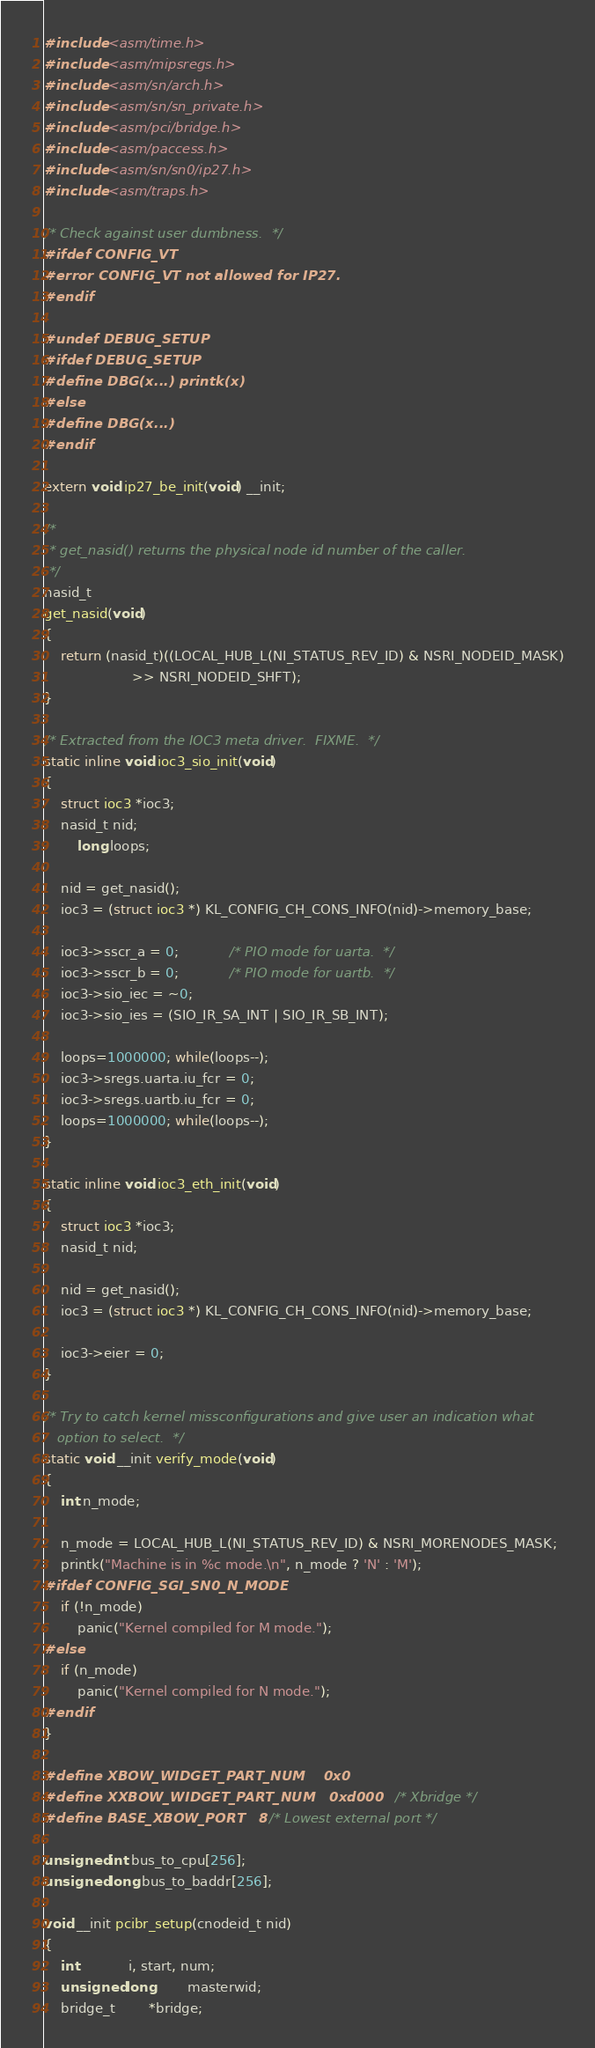<code> <loc_0><loc_0><loc_500><loc_500><_C_>#include <asm/time.h>
#include <asm/mipsregs.h>
#include <asm/sn/arch.h>
#include <asm/sn/sn_private.h>
#include <asm/pci/bridge.h>
#include <asm/paccess.h>
#include <asm/sn/sn0/ip27.h>
#include <asm/traps.h>

/* Check against user dumbness.  */
#ifdef CONFIG_VT
#error CONFIG_VT not allowed for IP27.
#endif

#undef DEBUG_SETUP
#ifdef DEBUG_SETUP
#define DBG(x...) printk(x)
#else
#define DBG(x...)
#endif

extern void ip27_be_init(void) __init;

/*
 * get_nasid() returns the physical node id number of the caller.
 */
nasid_t
get_nasid(void)
{
	return (nasid_t)((LOCAL_HUB_L(NI_STATUS_REV_ID) & NSRI_NODEID_MASK)
	                 >> NSRI_NODEID_SHFT);
}

/* Extracted from the IOC3 meta driver.  FIXME.  */
static inline void ioc3_sio_init(void)
{
	struct ioc3 *ioc3;
	nasid_t nid;
        long loops;

	nid = get_nasid();
	ioc3 = (struct ioc3 *) KL_CONFIG_CH_CONS_INFO(nid)->memory_base;

	ioc3->sscr_a = 0;			/* PIO mode for uarta.  */
	ioc3->sscr_b = 0;			/* PIO mode for uartb.  */
	ioc3->sio_iec = ~0;
	ioc3->sio_ies = (SIO_IR_SA_INT | SIO_IR_SB_INT);

	loops=1000000; while(loops--);
	ioc3->sregs.uarta.iu_fcr = 0;
	ioc3->sregs.uartb.iu_fcr = 0;
	loops=1000000; while(loops--);
}

static inline void ioc3_eth_init(void)
{
	struct ioc3 *ioc3;
	nasid_t nid;

	nid = get_nasid();
	ioc3 = (struct ioc3 *) KL_CONFIG_CH_CONS_INFO(nid)->memory_base;

	ioc3->eier = 0;
}

/* Try to catch kernel missconfigurations and give user an indication what
   option to select.  */
static void __init verify_mode(void)
{
	int n_mode;

	n_mode = LOCAL_HUB_L(NI_STATUS_REV_ID) & NSRI_MORENODES_MASK;
	printk("Machine is in %c mode.\n", n_mode ? 'N' : 'M');
#ifdef CONFIG_SGI_SN0_N_MODE
	if (!n_mode)
		panic("Kernel compiled for M mode.");
#else
	if (n_mode)
		panic("Kernel compiled for N mode.");
#endif
}

#define XBOW_WIDGET_PART_NUM    0x0
#define XXBOW_WIDGET_PART_NUM   0xd000          /* Xbridge */
#define BASE_XBOW_PORT  	8     /* Lowest external port */

unsigned int bus_to_cpu[256];
unsigned long bus_to_baddr[256];

void __init pcibr_setup(cnodeid_t nid)
{
	int 			i, start, num;
	unsigned long		masterwid;
	bridge_t 		*bridge;</code> 